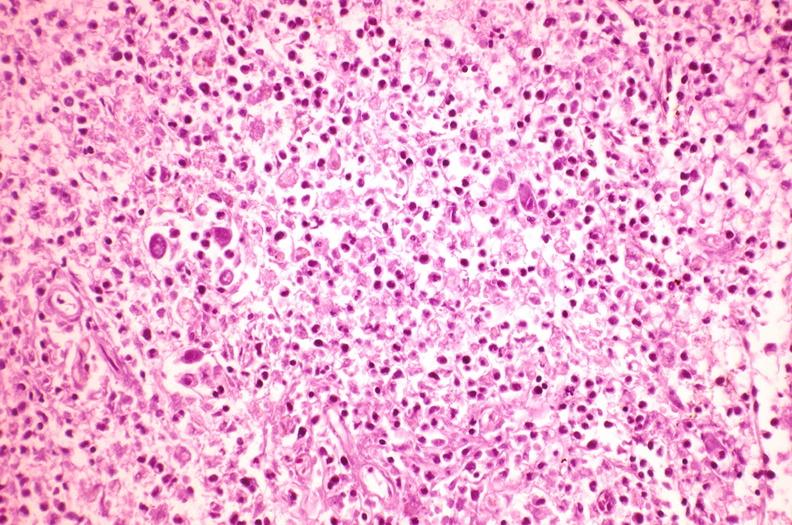does thymus show spleen, cytomegalovirus?
Answer the question using a single word or phrase. No 